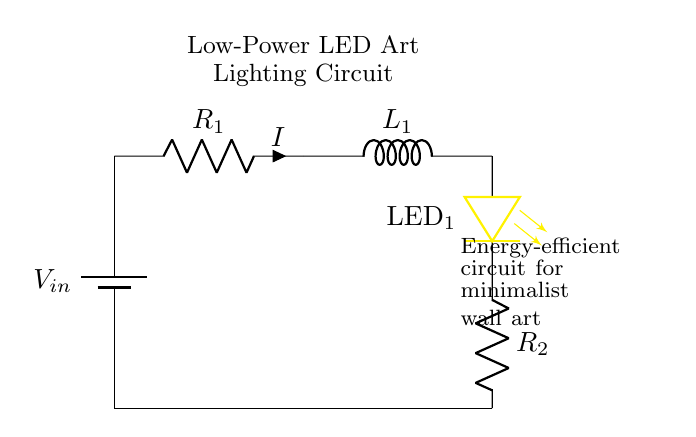What is the input voltage labeled in the circuit? The input voltage is labeled as \( V_{in} \), which is placed near the battery component at the top of the circuit.
Answer: V in What are the components connected in series after the battery? The components connected in series are the resistor \( R_1 \) and the inductor \( L_1 \), with the current \( I \) flowing through them.
Answer: Resistor \( R_1 \) and inductor \( L_1 \) What is the purpose of \( R_2 \) in the circuit? \( R_2 \) acts as a current limiting resistor for the LED \( \text{LED}_1 \), preventing excessive current that could damage it.
Answer: Current limiting How many resistors are present in the circuit? There are two resistors: \( R_1 \) and \( R_2 \), identified by their respective labels in the circuit diagram.
Answer: Two Why is it important to use an inductor in this LED lighting circuit? The inductor decreases the rate of current change in the circuit, helping to stabilize the current flowing to the LED, enhancing energy efficiency and reducing flicker.
Answer: Current stabilization What is the type of LED used in the circuit? The LED is labeled as \( \text{LED}_1 \) and is indicated by the yellow symbol in the circuit representation.
Answer: LED 1 What role does \( L_1 \) play regarding energy efficiency? \( L_1 \) stores energy in a magnetic field during operation, which helps in smoothing out the current and reducing energy losses in the circuit, leading to greater efficiency.
Answer: Energy storage 